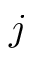<formula> <loc_0><loc_0><loc_500><loc_500>j</formula> 